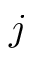<formula> <loc_0><loc_0><loc_500><loc_500>j</formula> 